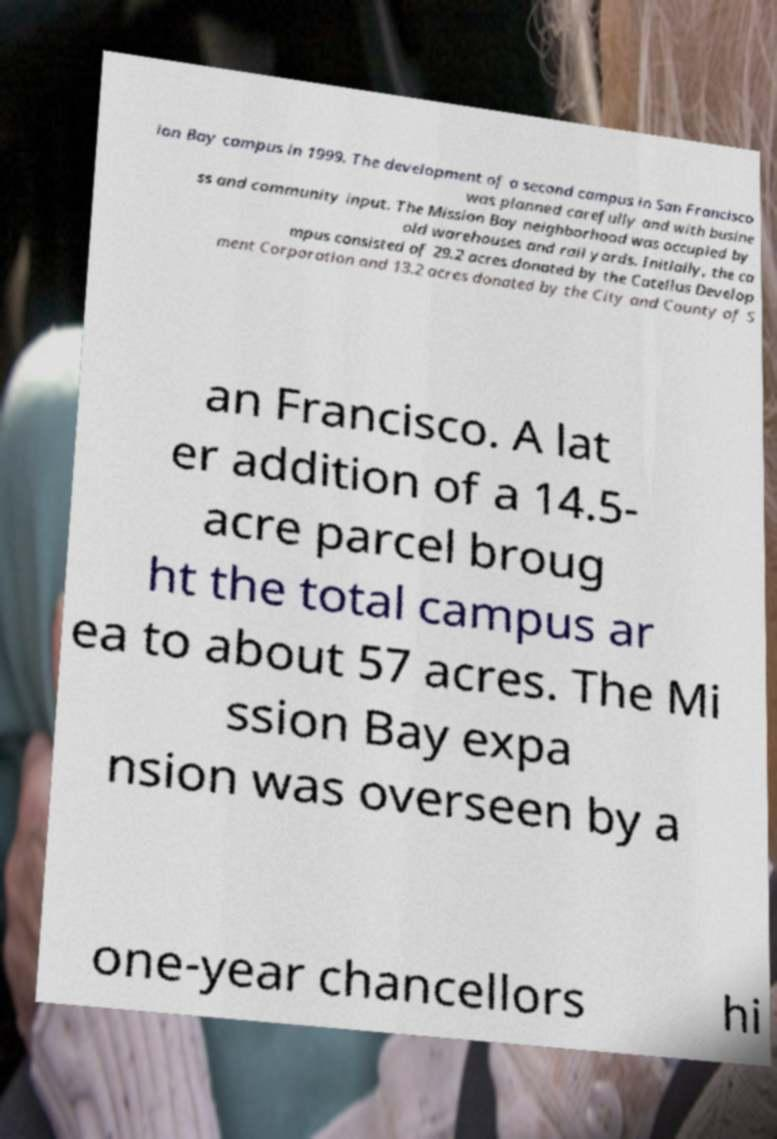Could you extract and type out the text from this image? ion Bay campus in 1999. The development of a second campus in San Francisco was planned carefully and with busine ss and community input. The Mission Bay neighborhood was occupied by old warehouses and rail yards. Initially, the ca mpus consisted of 29.2 acres donated by the Catellus Develop ment Corporation and 13.2 acres donated by the City and County of S an Francisco. A lat er addition of a 14.5- acre parcel broug ht the total campus ar ea to about 57 acres. The Mi ssion Bay expa nsion was overseen by a one-year chancellors hi 